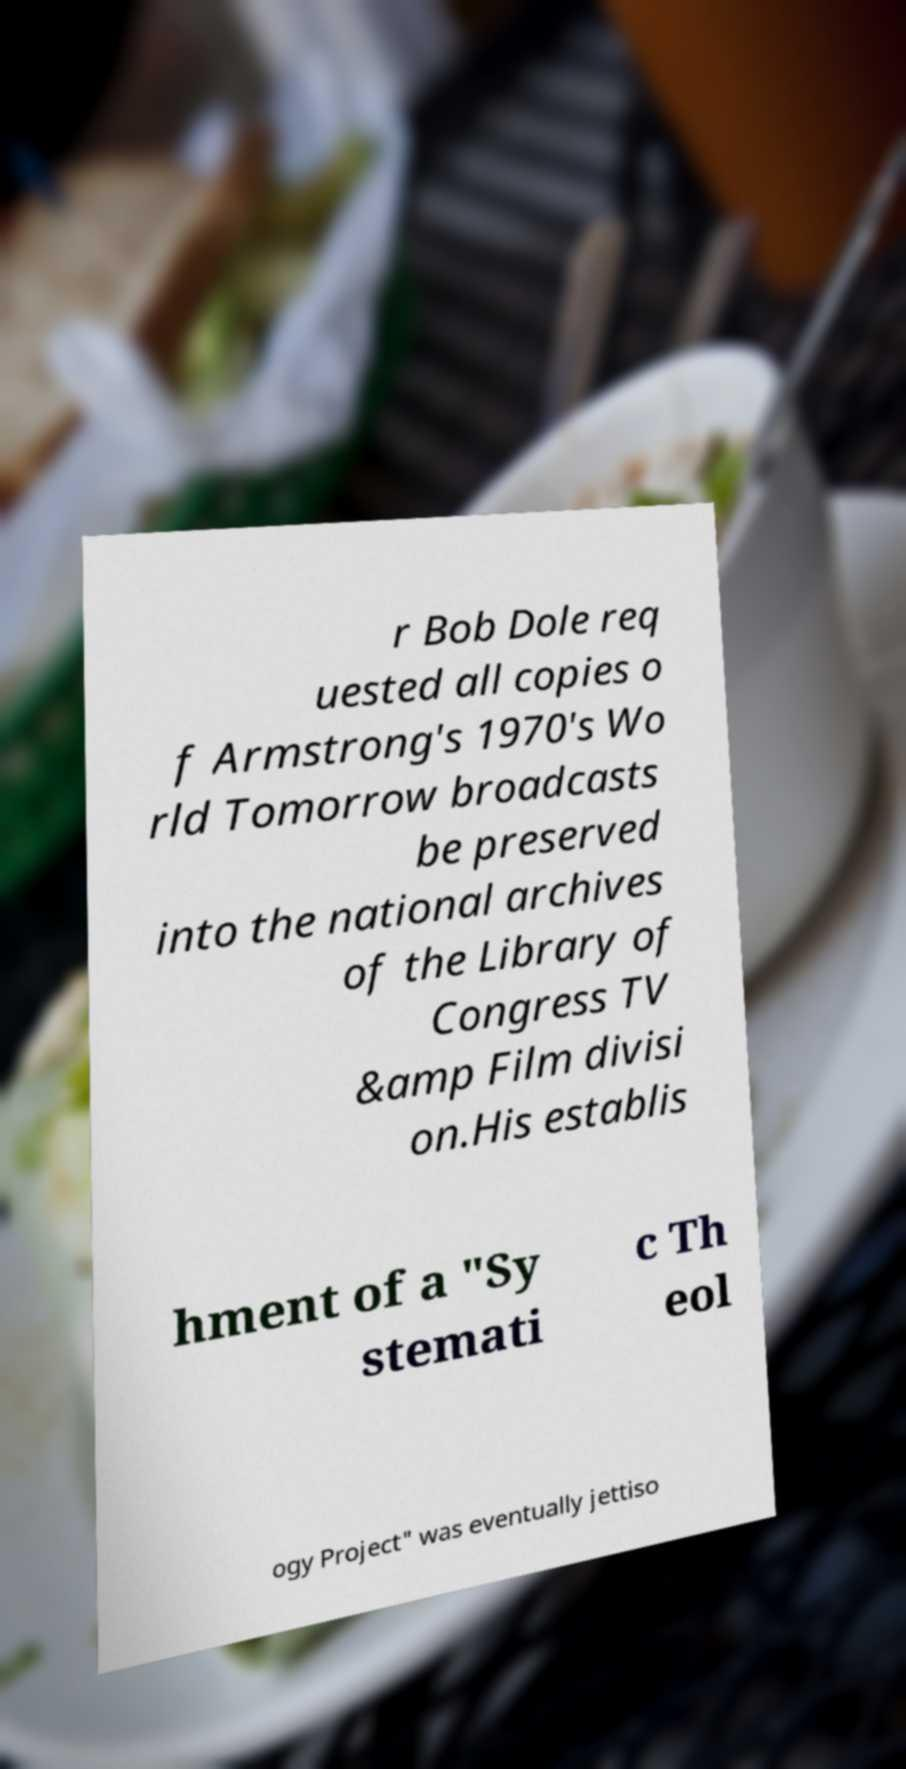What messages or text are displayed in this image? I need them in a readable, typed format. r Bob Dole req uested all copies o f Armstrong's 1970's Wo rld Tomorrow broadcasts be preserved into the national archives of the Library of Congress TV &amp Film divisi on.His establis hment of a "Sy stemati c Th eol ogy Project" was eventually jettiso 